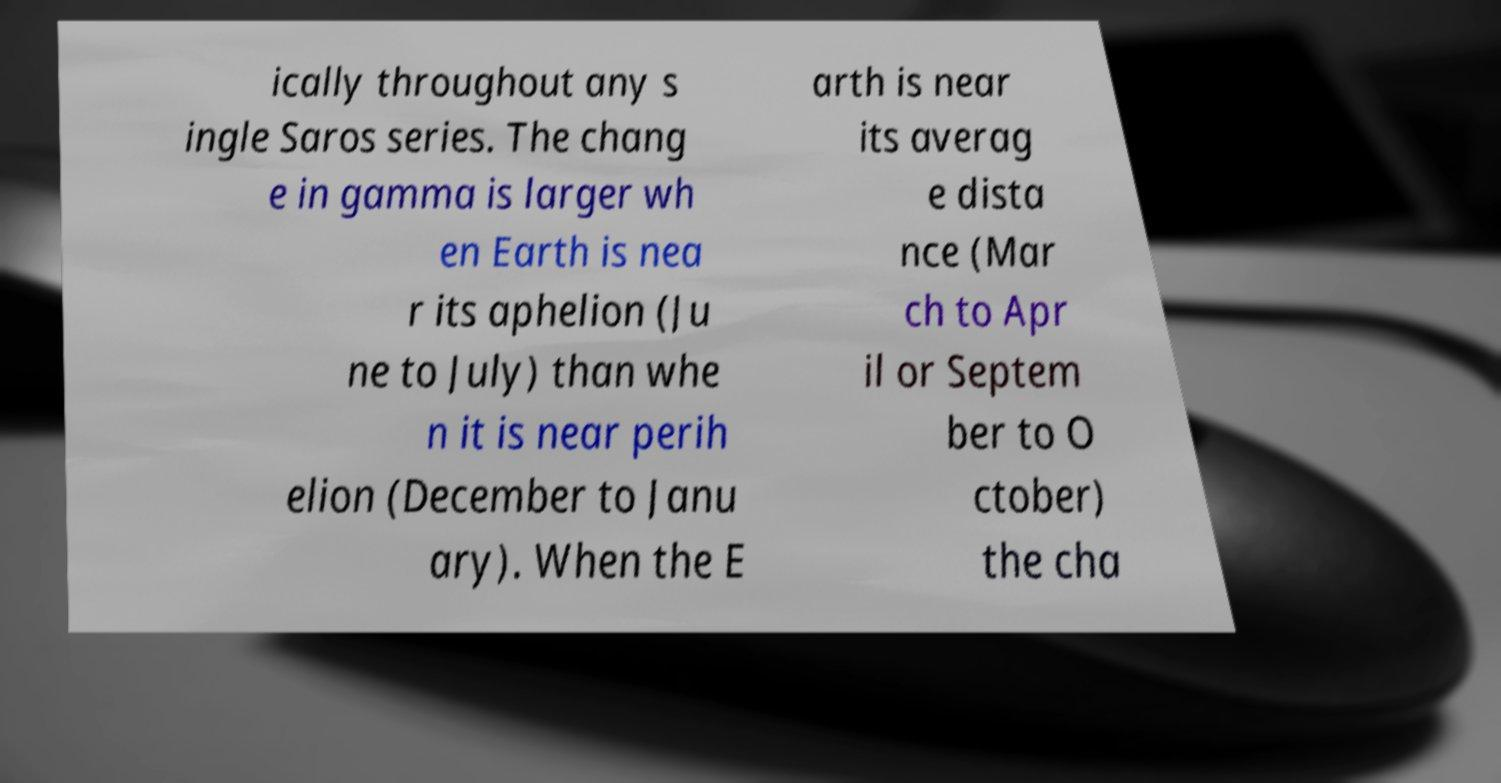Can you accurately transcribe the text from the provided image for me? ically throughout any s ingle Saros series. The chang e in gamma is larger wh en Earth is nea r its aphelion (Ju ne to July) than whe n it is near perih elion (December to Janu ary). When the E arth is near its averag e dista nce (Mar ch to Apr il or Septem ber to O ctober) the cha 